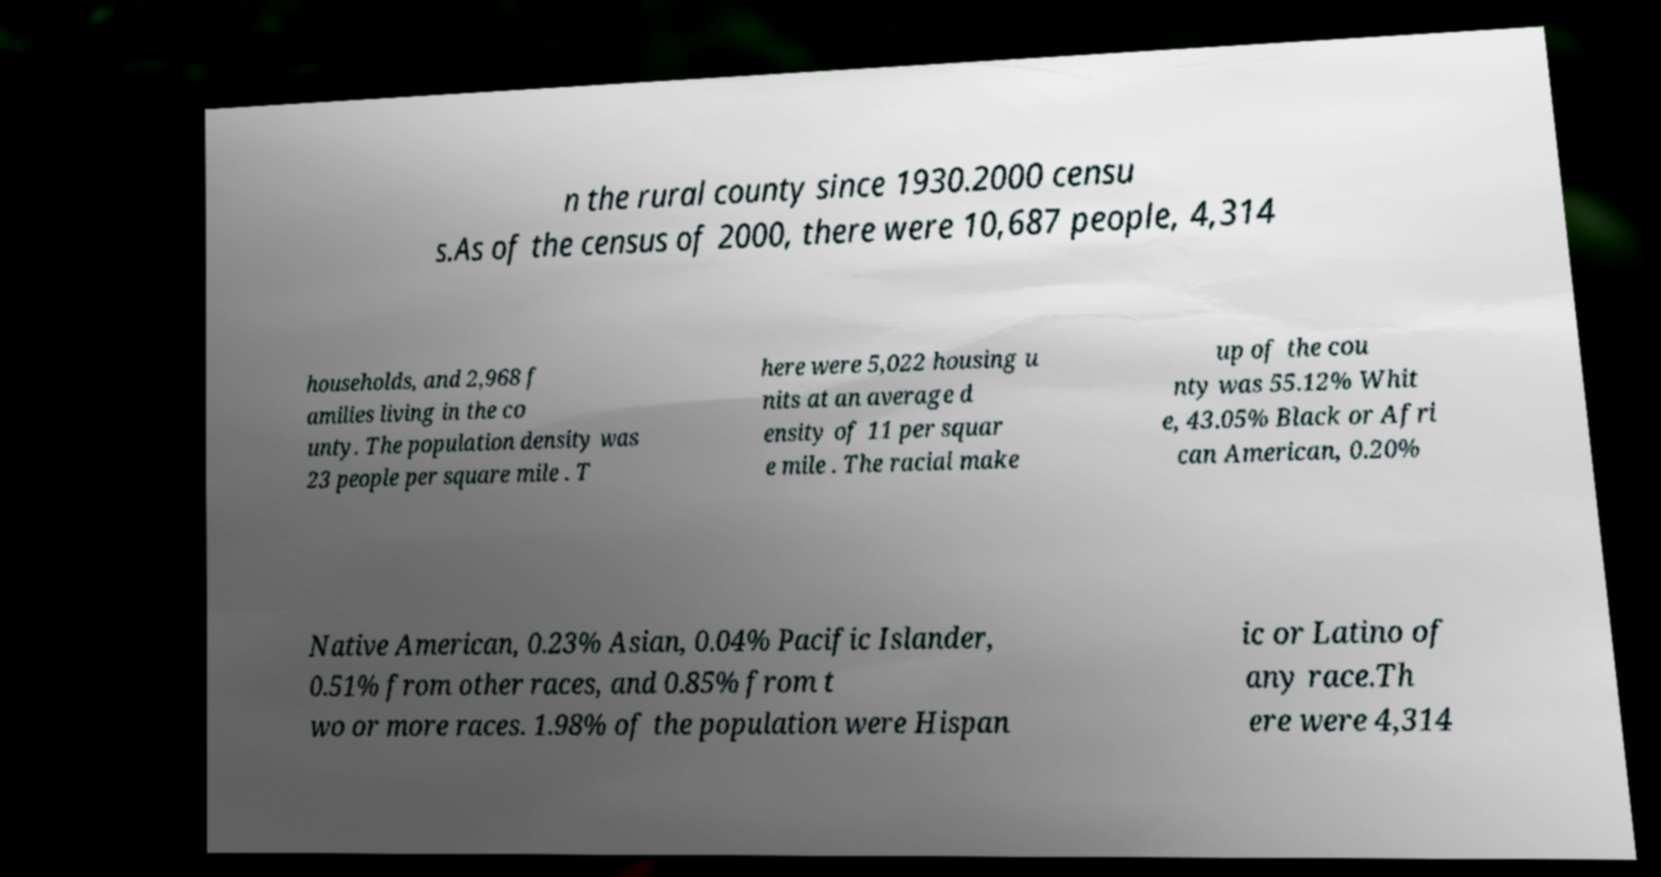Can you accurately transcribe the text from the provided image for me? n the rural county since 1930.2000 censu s.As of the census of 2000, there were 10,687 people, 4,314 households, and 2,968 f amilies living in the co unty. The population density was 23 people per square mile . T here were 5,022 housing u nits at an average d ensity of 11 per squar e mile . The racial make up of the cou nty was 55.12% Whit e, 43.05% Black or Afri can American, 0.20% Native American, 0.23% Asian, 0.04% Pacific Islander, 0.51% from other races, and 0.85% from t wo or more races. 1.98% of the population were Hispan ic or Latino of any race.Th ere were 4,314 